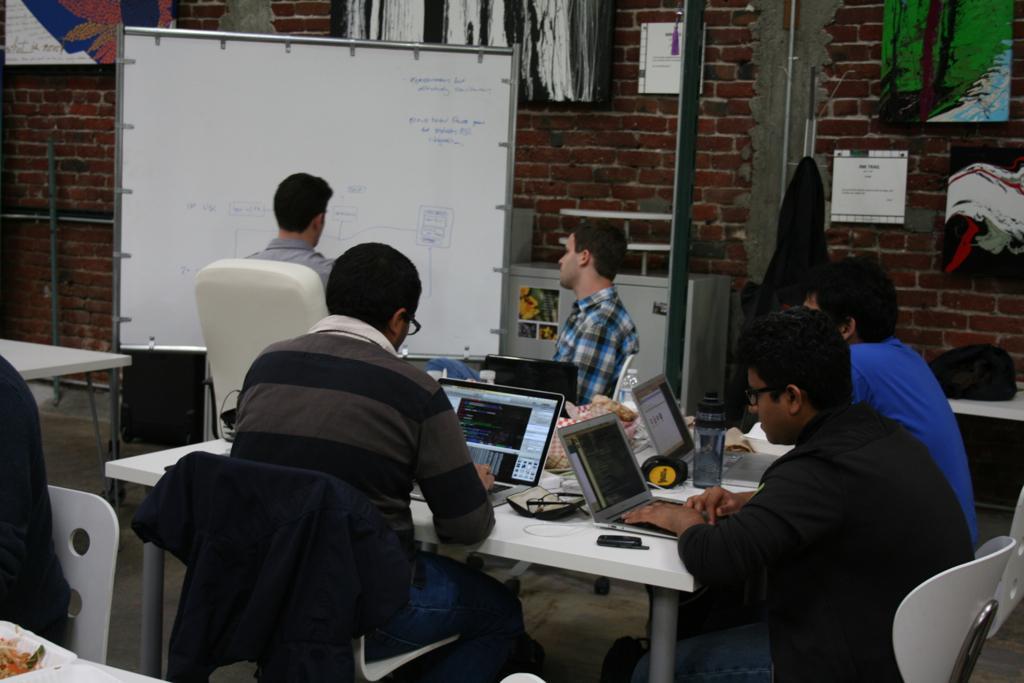Could you give a brief overview of what you see in this image? In this image we can see a group of people sitting on the chairs beside a table containing some laptops, glasses, boxes, a bottle and some objects on it. We can also see a cloth on a chair. On the backside we can see a bag on a table, some boards on a wall, a pole and a board with some text on it. On the left bottom we can see a person sitting on a chair beside a table containing some food in a plate. 